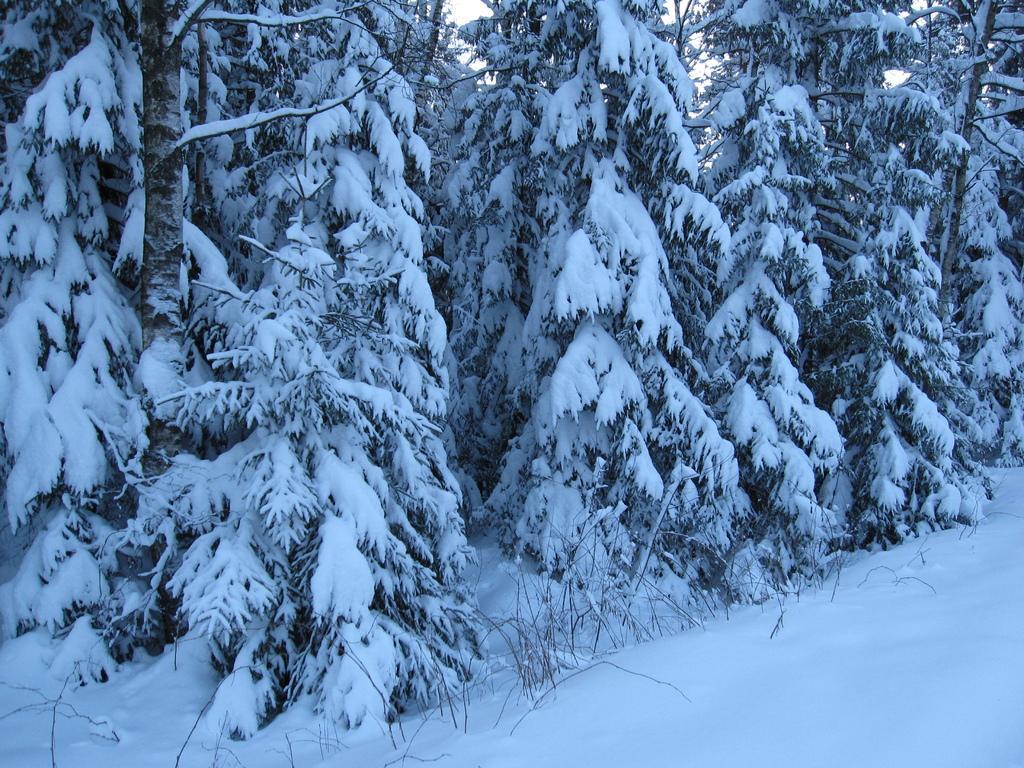Please provide a concise description of this image. In this picture I can see snow on the land and on some trees. There are some trees in this picture. In the background there is a sky. 